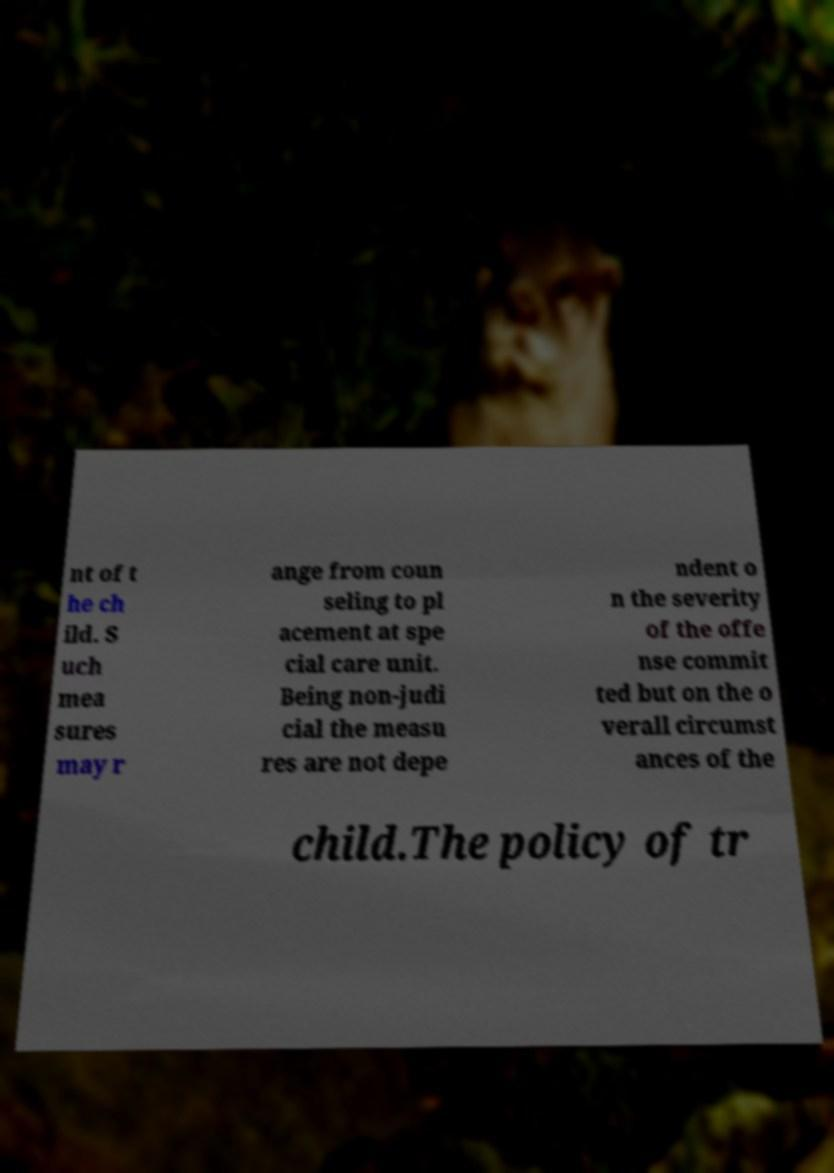Could you extract and type out the text from this image? nt of t he ch ild. S uch mea sures may r ange from coun seling to pl acement at spe cial care unit. Being non-judi cial the measu res are not depe ndent o n the severity of the offe nse commit ted but on the o verall circumst ances of the child.The policy of tr 